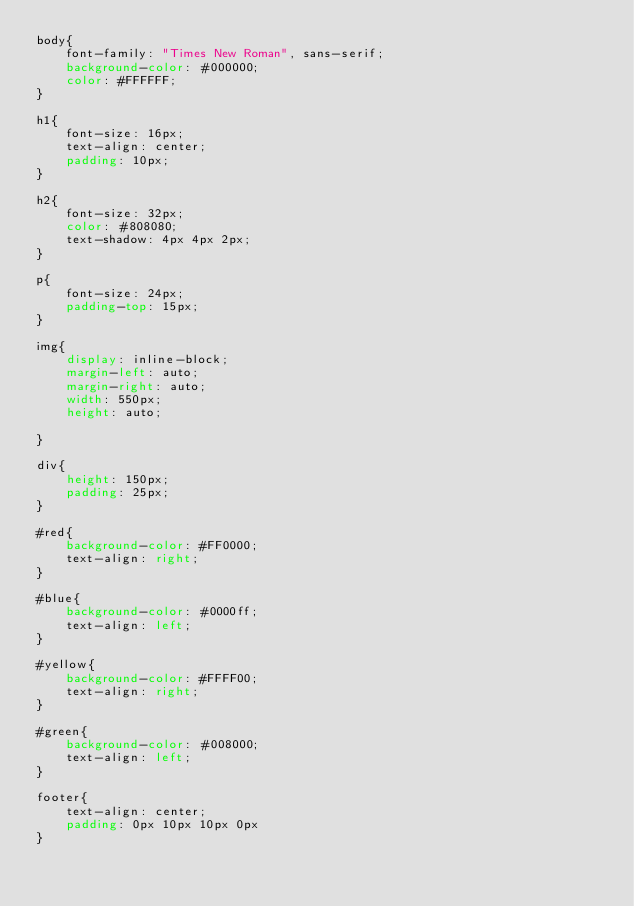Convert code to text. <code><loc_0><loc_0><loc_500><loc_500><_CSS_>body{
    font-family: "Times New Roman", sans-serif;
    background-color: #000000;
    color: #FFFFFF;
}

h1{
    font-size: 16px;
    text-align: center;
    padding: 10px;
}

h2{
    font-size: 32px;
    color: #808080;
    text-shadow: 4px 4px 2px;
}

p{
    font-size: 24px;
    padding-top: 15px;
}

img{
    display: inline-block;
    margin-left: auto;
    margin-right: auto;
    width: 550px;
    height: auto;

}

div{
    height: 150px;
    padding: 25px;
}

#red{
    background-color: #FF0000;
    text-align: right;
}

#blue{
    background-color: #0000ff;
    text-align: left;
}

#yellow{
    background-color: #FFFF00;
    text-align: right;
}

#green{
    background-color: #008000;
    text-align: left;
}

footer{
    text-align: center;
    padding: 0px 10px 10px 0px
}</code> 